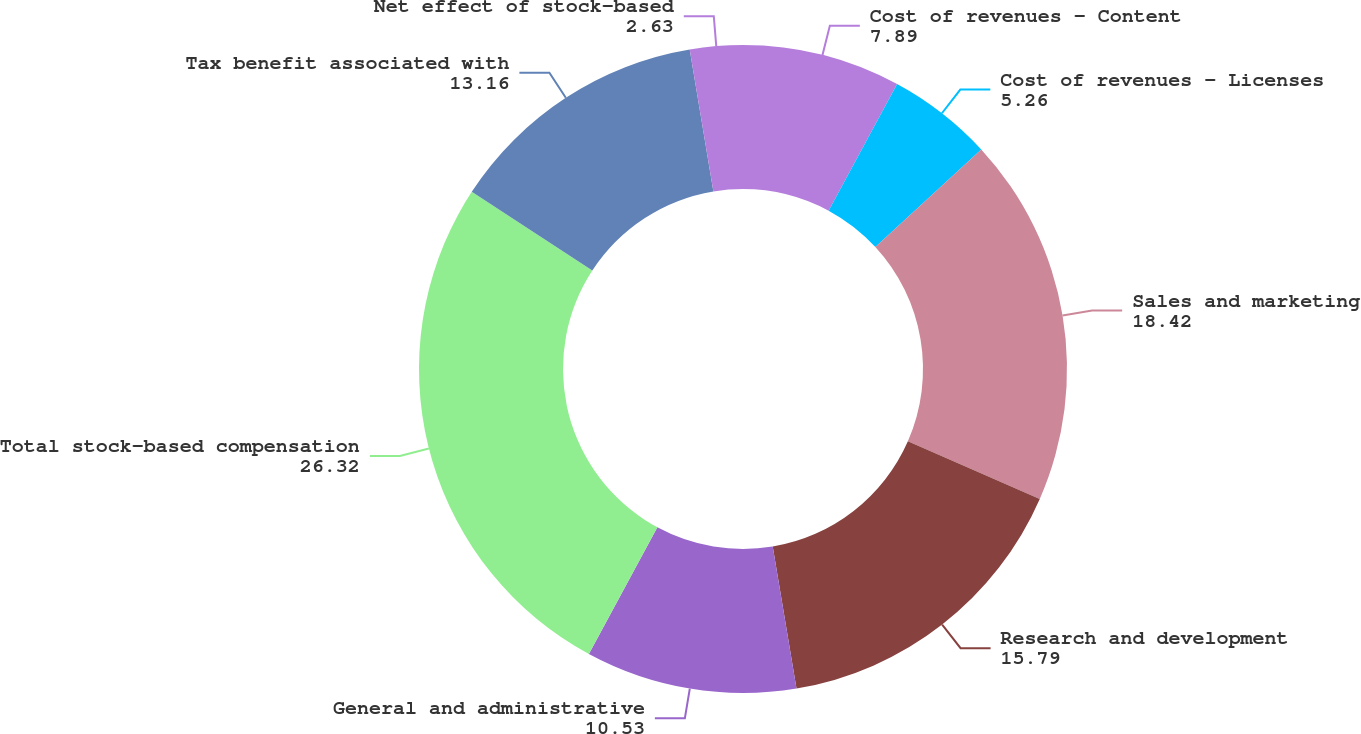<chart> <loc_0><loc_0><loc_500><loc_500><pie_chart><fcel>Cost of revenues - Content<fcel>Cost of revenues - Licenses<fcel>Sales and marketing<fcel>Research and development<fcel>General and administrative<fcel>Total stock-based compensation<fcel>Tax benefit associated with<fcel>Net effect of stock-based<nl><fcel>7.89%<fcel>5.26%<fcel>18.42%<fcel>15.79%<fcel>10.53%<fcel>26.32%<fcel>13.16%<fcel>2.63%<nl></chart> 